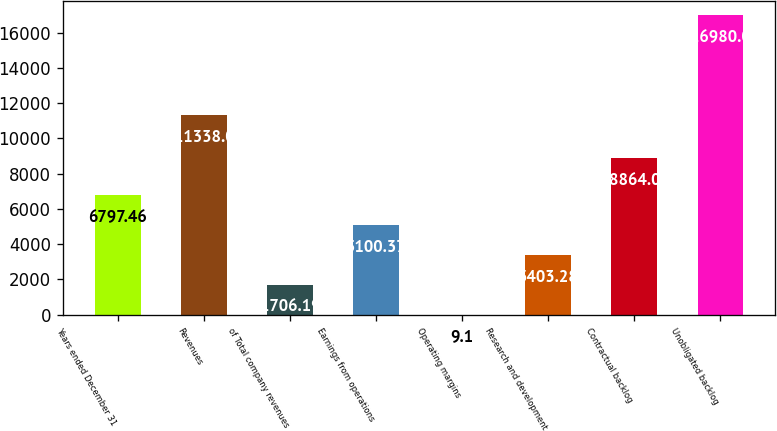Convert chart. <chart><loc_0><loc_0><loc_500><loc_500><bar_chart><fcel>Years ended December 31<fcel>Revenues<fcel>of Total company revenues<fcel>Earnings from operations<fcel>Operating margins<fcel>Research and development<fcel>Contractual backlog<fcel>Unobligated backlog<nl><fcel>6797.46<fcel>11338<fcel>1706.19<fcel>5100.37<fcel>9.1<fcel>3403.28<fcel>8864<fcel>16980<nl></chart> 